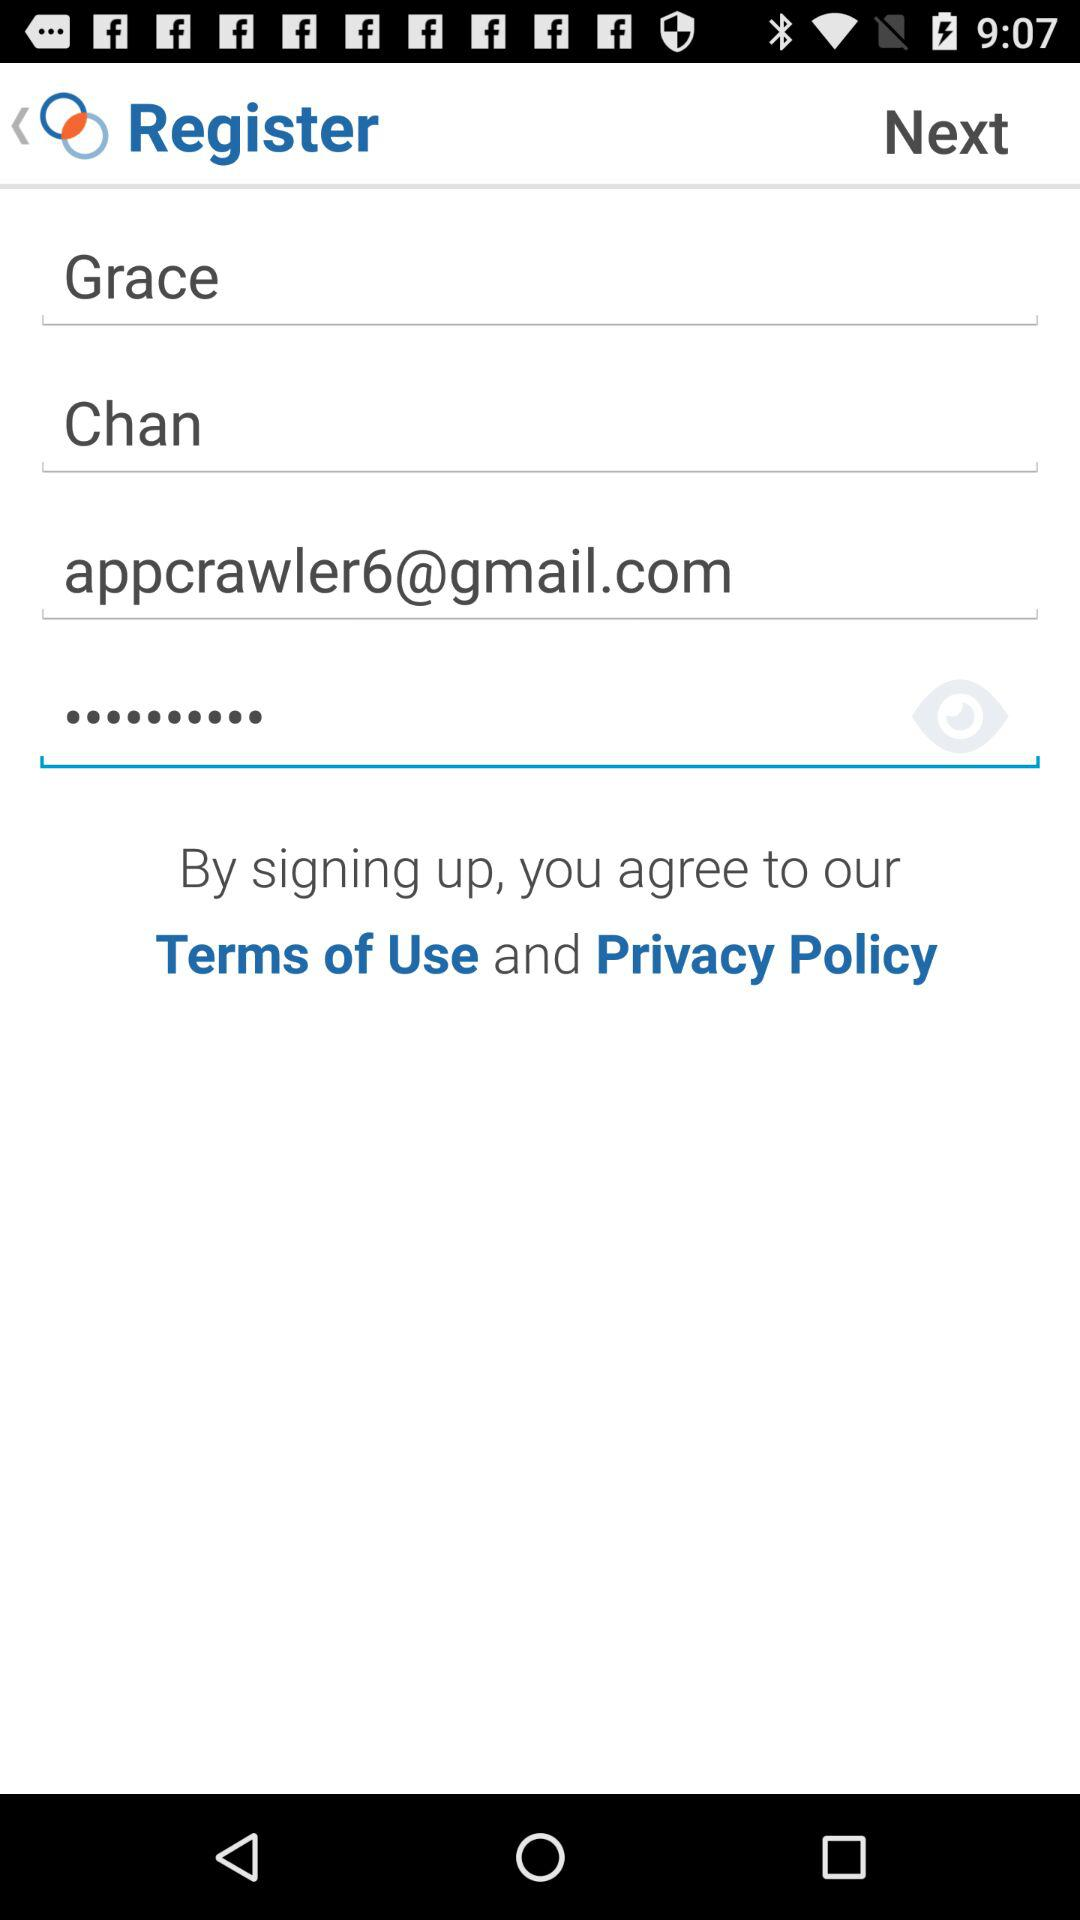How many text fields are there on this registration form?
Answer the question using a single word or phrase. 4 